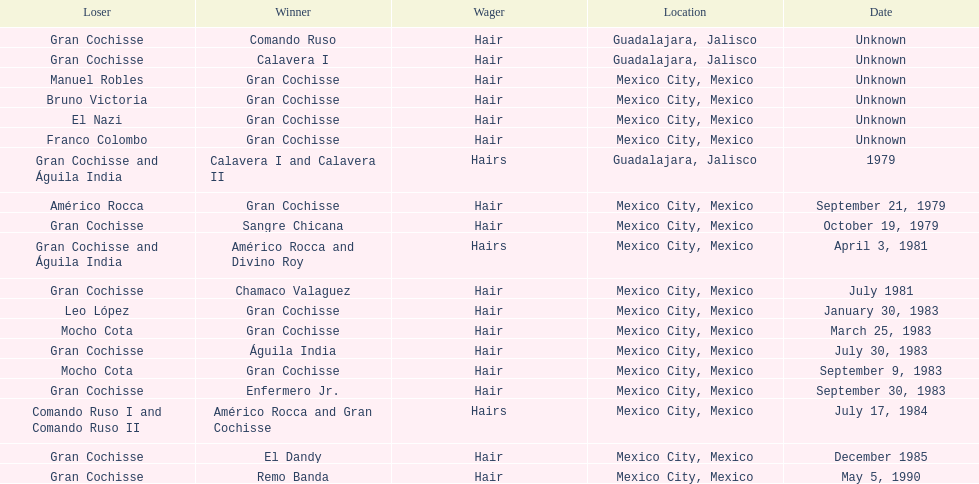How many times has the wager been hair? 16. 